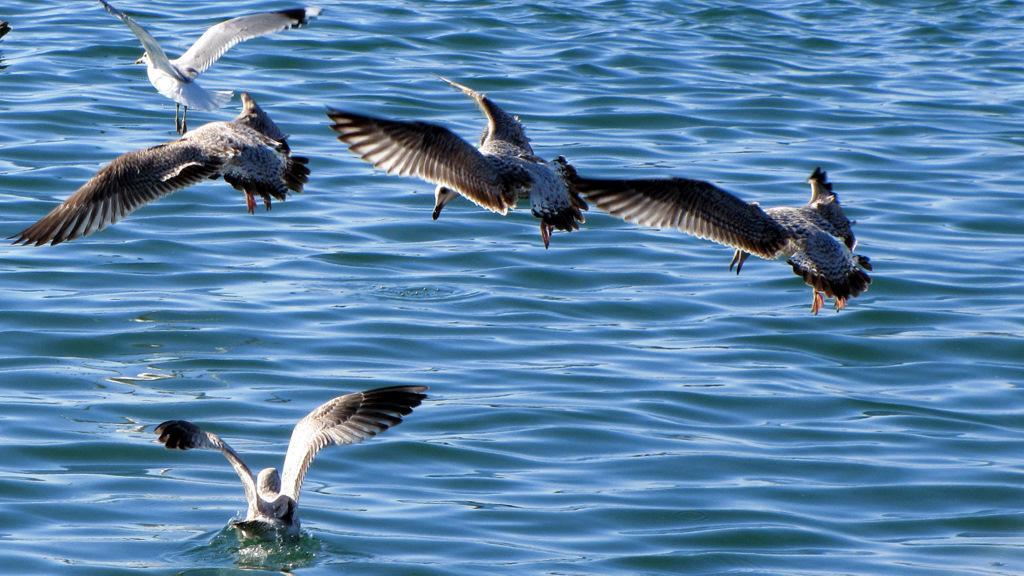How would you summarize this image in a sentence or two? This picture is clicked outside and we can see there are some birds seems to be flying and we can see another bird in the water body. 